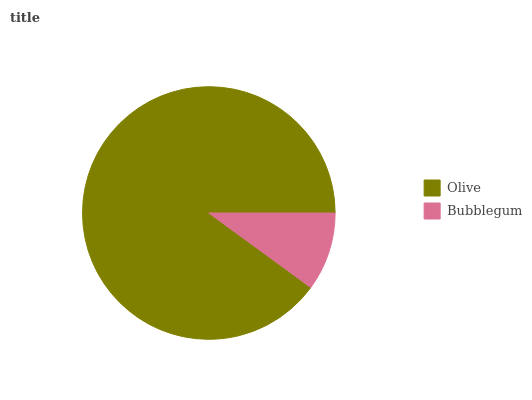Is Bubblegum the minimum?
Answer yes or no. Yes. Is Olive the maximum?
Answer yes or no. Yes. Is Bubblegum the maximum?
Answer yes or no. No. Is Olive greater than Bubblegum?
Answer yes or no. Yes. Is Bubblegum less than Olive?
Answer yes or no. Yes. Is Bubblegum greater than Olive?
Answer yes or no. No. Is Olive less than Bubblegum?
Answer yes or no. No. Is Olive the high median?
Answer yes or no. Yes. Is Bubblegum the low median?
Answer yes or no. Yes. Is Bubblegum the high median?
Answer yes or no. No. Is Olive the low median?
Answer yes or no. No. 